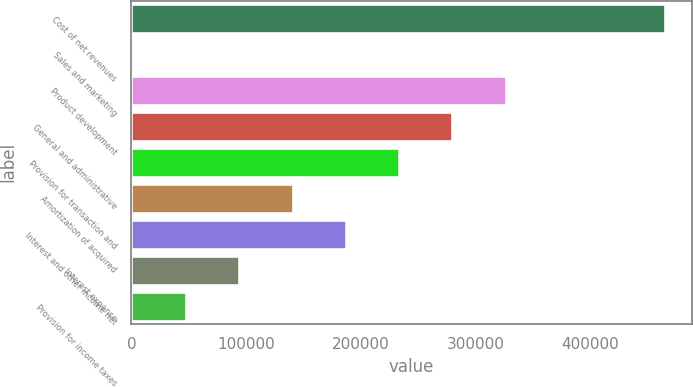Convert chart to OTSL. <chart><loc_0><loc_0><loc_500><loc_500><bar_chart><fcel>Cost of net revenues<fcel>Sales and marketing<fcel>Product development<fcel>General and administrative<fcel>Provision for transaction and<fcel>Amortization of acquired<fcel>Interest and other income net<fcel>Interest expense<fcel>Provision for income taxes<nl><fcel>465097<fcel>1259<fcel>325946<fcel>279562<fcel>233178<fcel>140410<fcel>186794<fcel>94026.6<fcel>47642.8<nl></chart> 